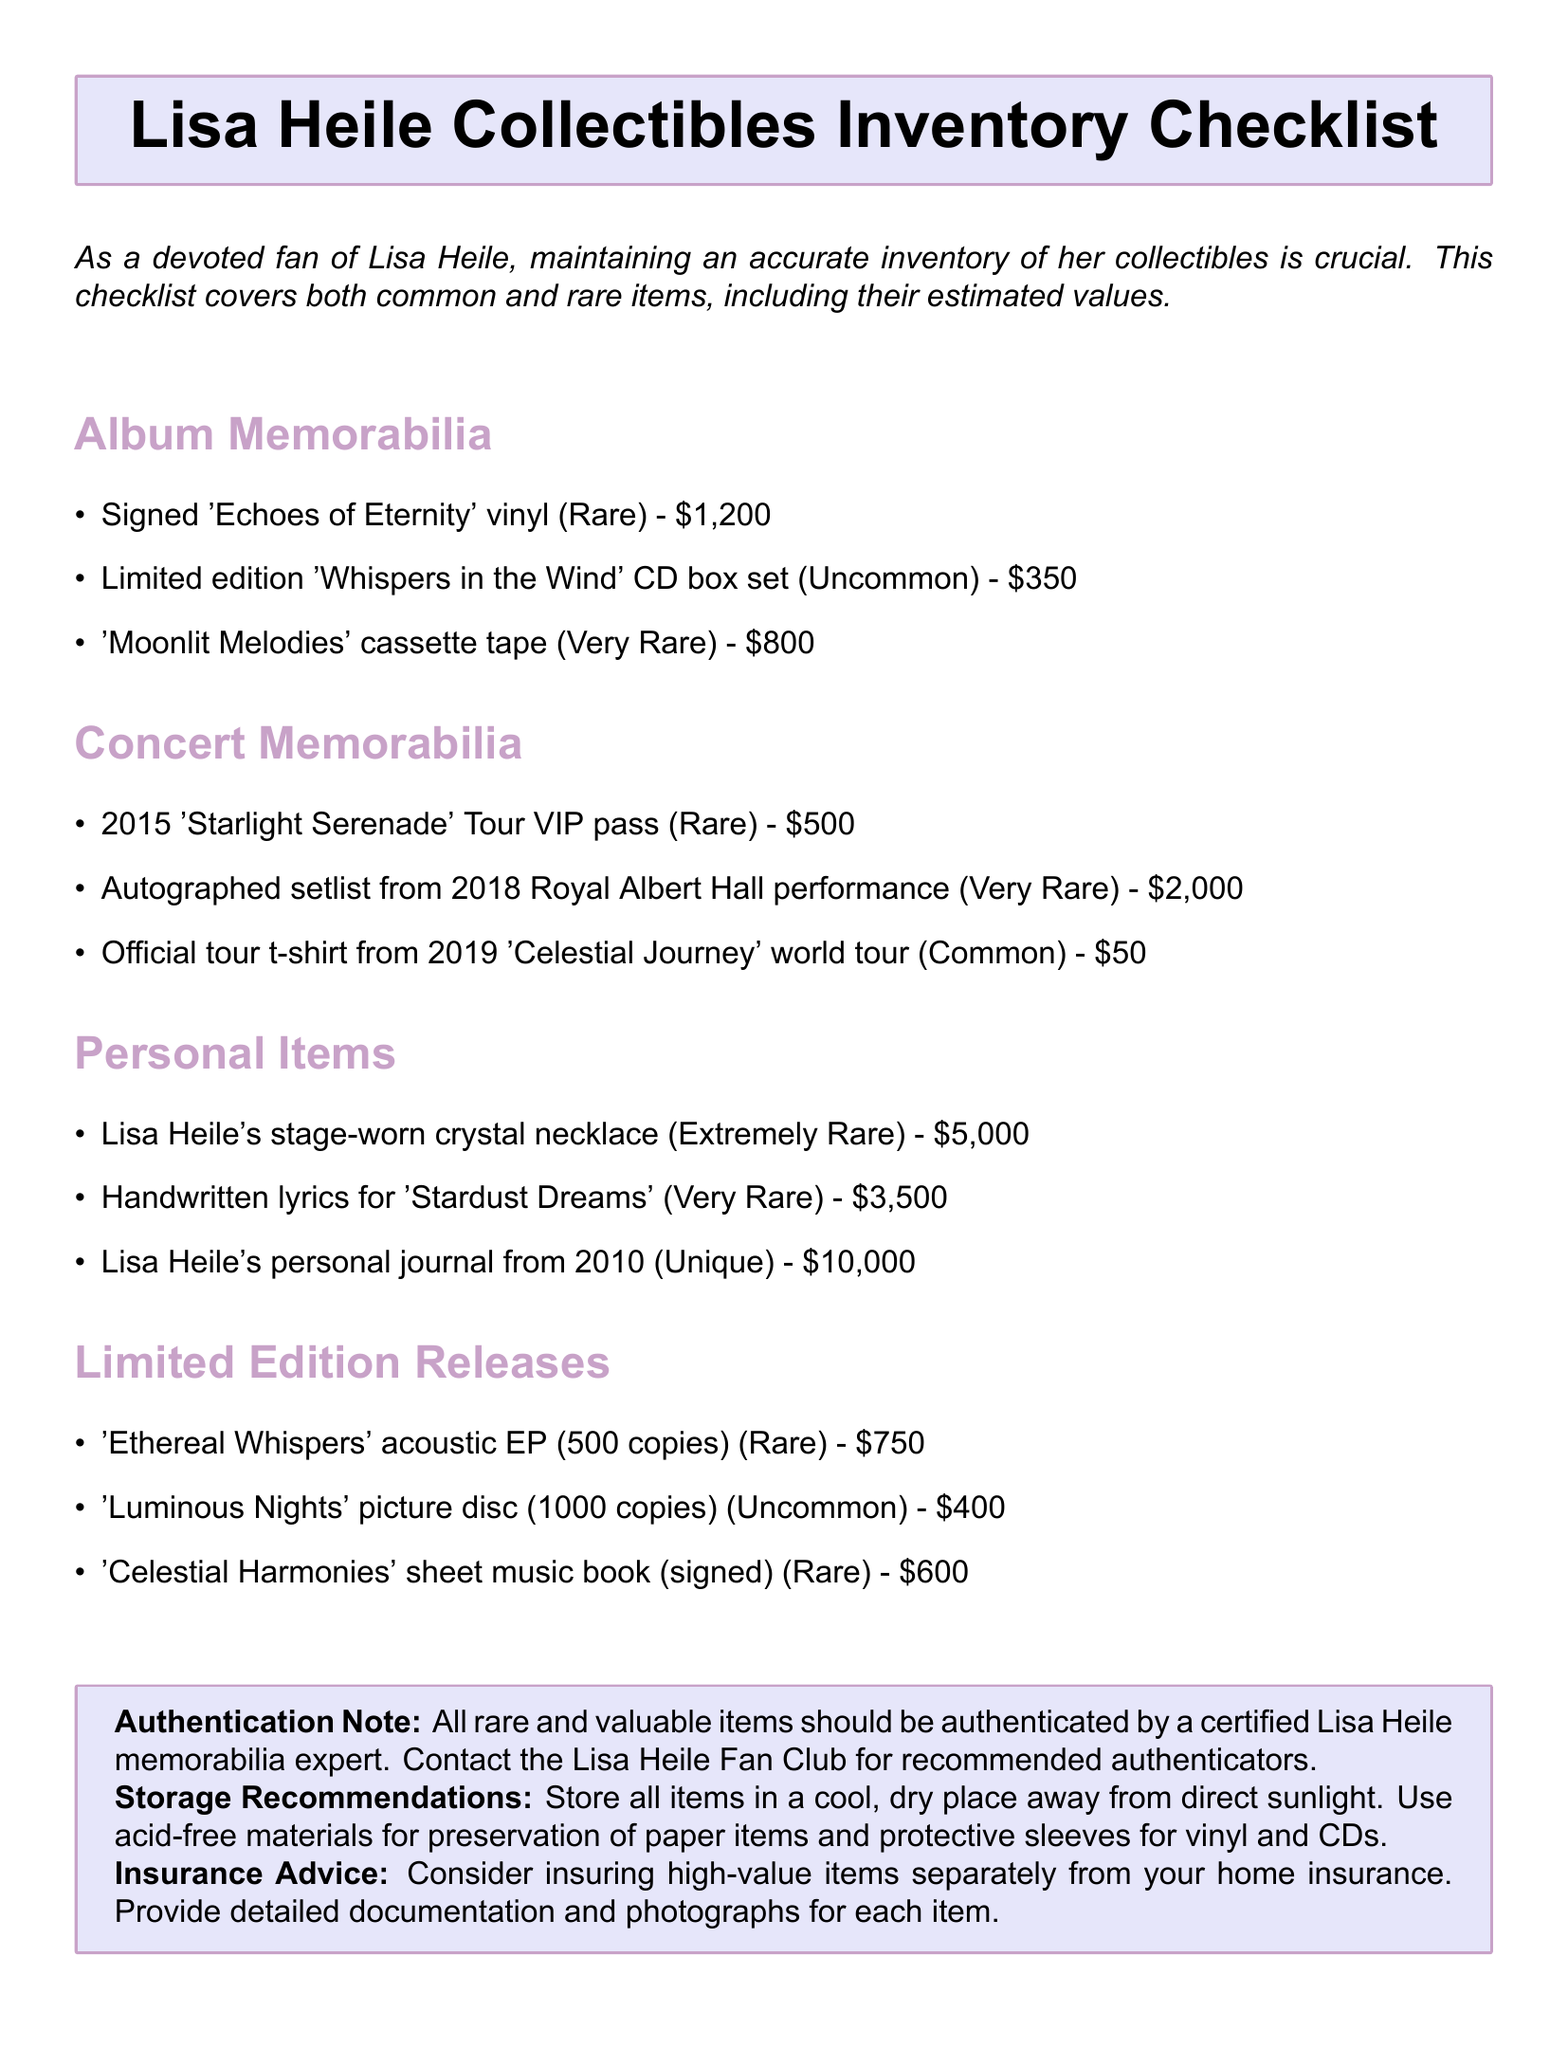What is the estimated value of Lisa Heile's personal journal from 2010? The estimated value of Lisa Heile's personal journal from 2010 is listed in the document.
Answer: $10,000 How many copies of the 'Ethereal Whispers' acoustic EP were released? The document states that there were 500 copies of the 'Ethereal Whispers' acoustic EP released.
Answer: 500 copies What is the rarity of the autographed setlist from the 2018 Royal Albert Hall performance? The document categorizes the autographed setlist from the 2018 Royal Albert Hall performance as 'Very Rare.'
Answer: Very Rare Which category contains the most valuable item? To determine this, we need to evaluate the items in each category based on their estimated values in the document. The 'Personal Items' category contains the item worth $10,000, the highest value.
Answer: Personal Items What authentication advice is given in the memo? The document includes a note advising that all rare and valuable items should be authenticated by a certified expert.
Answer: Certified Lisa Heile memorabilia expert What is the estimated value of the signed 'Echoes of Eternity' vinyl? The estimated value of the signed 'Echoes of Eternity' vinyl is specifically mentioned in the document.
Answer: $1,200 